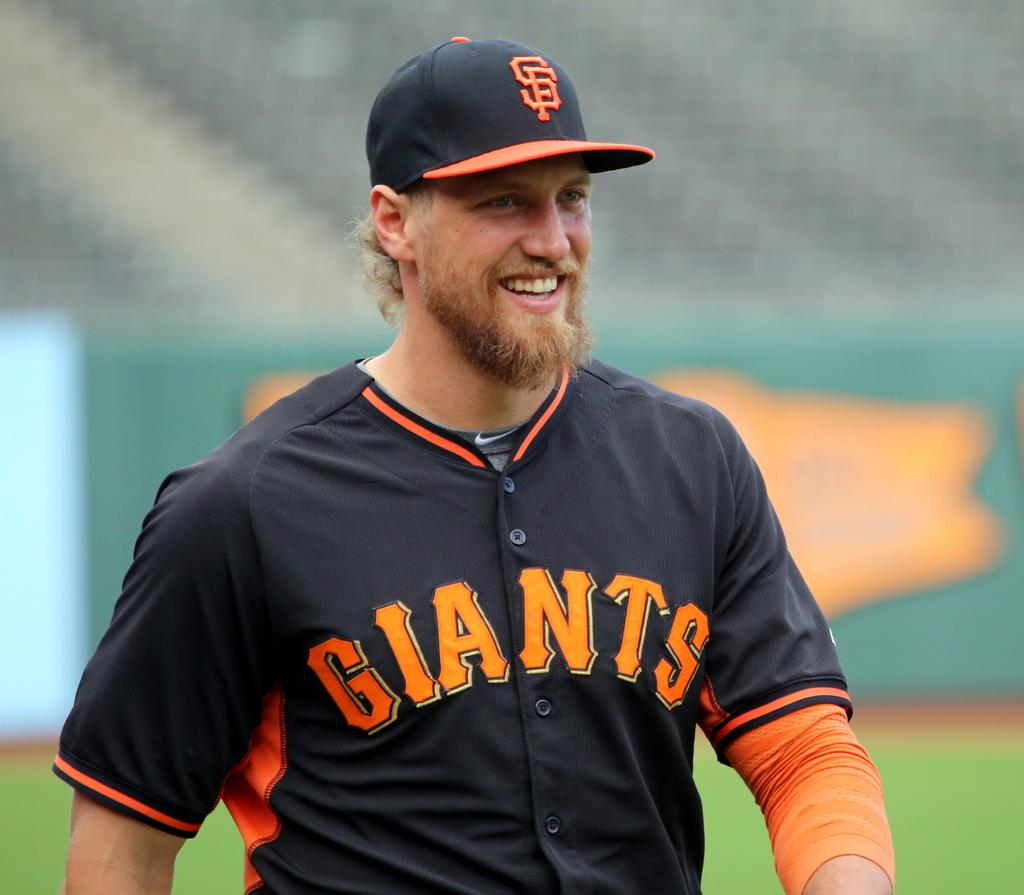<image>
Relay a brief, clear account of the picture shown. The baseball player is a member of the SF Giants. 